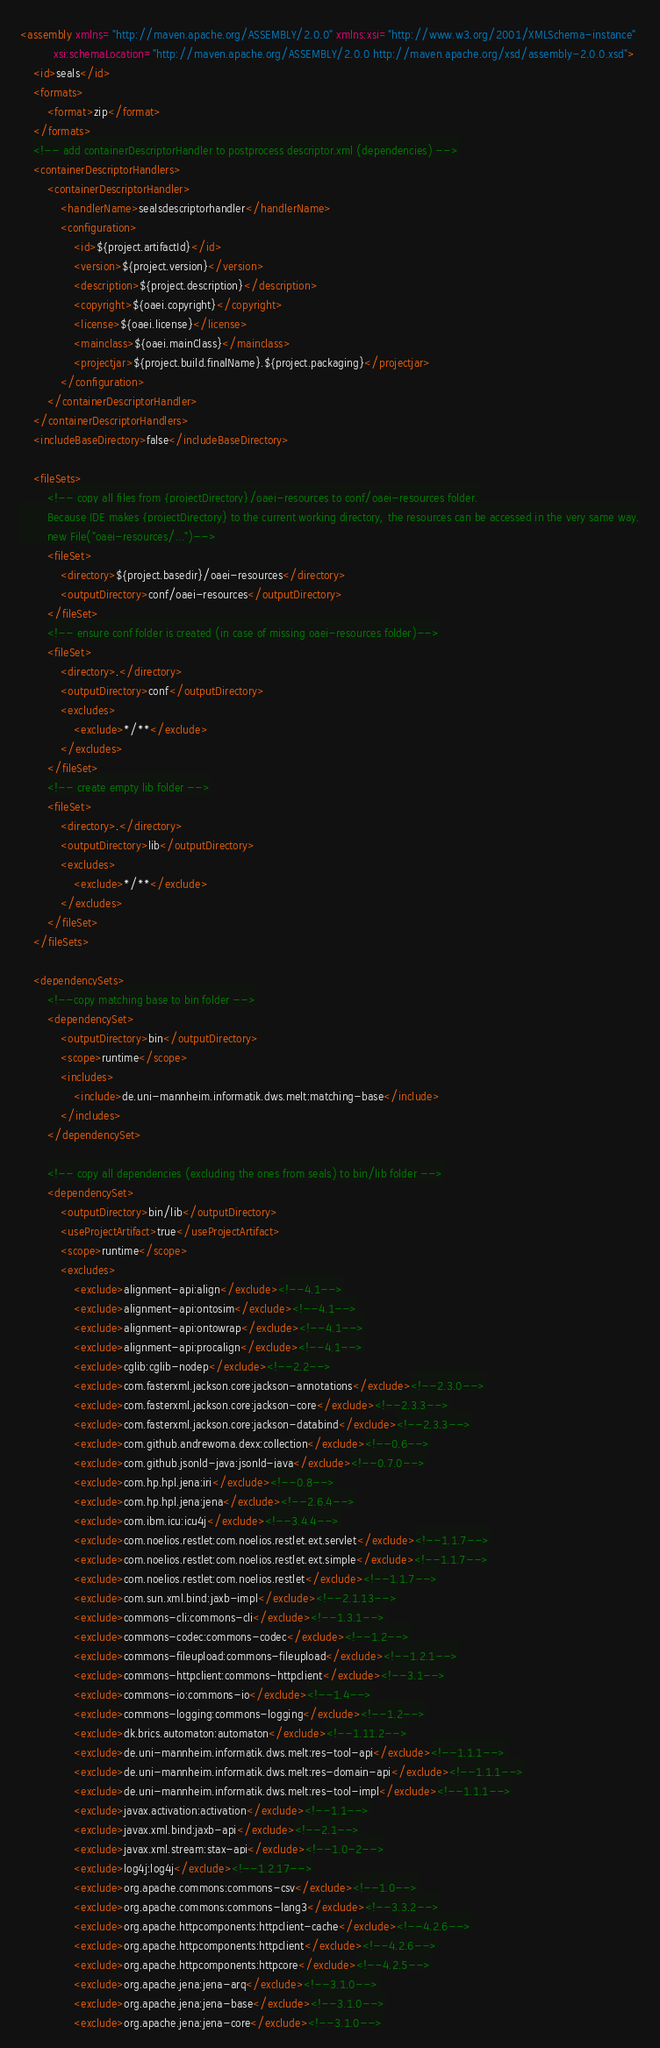<code> <loc_0><loc_0><loc_500><loc_500><_XML_><assembly xmlns="http://maven.apache.org/ASSEMBLY/2.0.0" xmlns:xsi="http://www.w3.org/2001/XMLSchema-instance"
          xsi:schemaLocation="http://maven.apache.org/ASSEMBLY/2.0.0 http://maven.apache.org/xsd/assembly-2.0.0.xsd">
    <id>seals</id>
    <formats>
        <format>zip</format>
    </formats>
    <!-- add containerDescriptorHandler to postprocess descriptor.xml (dependencies) -->
    <containerDescriptorHandlers>
        <containerDescriptorHandler>
            <handlerName>sealsdescriptorhandler</handlerName>
            <configuration>
                <id>${project.artifactId}</id>
                <version>${project.version}</version>
                <description>${project.description}</description>
                <copyright>${oaei.copyright}</copyright>
                <license>${oaei.license}</license>
                <mainclass>${oaei.mainClass}</mainclass>
                <projectjar>${project.build.finalName}.${project.packaging}</projectjar>
            </configuration>
        </containerDescriptorHandler>
    </containerDescriptorHandlers>
    <includeBaseDirectory>false</includeBaseDirectory>
        
    <fileSets>        
        <!-- copy all files from {projectDirectory}/oaei-resources to conf/oaei-resources folder.
        Because IDE makes {projectDirectory} to the current working directory, the resources can be accessed in the very same way.
        new File("oaei-resources/...")-->
        <fileSet>
            <directory>${project.basedir}/oaei-resources</directory>
            <outputDirectory>conf/oaei-resources</outputDirectory>
        </fileSet>
        <!-- ensure conf folder is created (in case of missing oaei-resources folder)-->
        <fileSet>
            <directory>.</directory>
            <outputDirectory>conf</outputDirectory>
            <excludes>
                <exclude>*/**</exclude>
            </excludes>
        </fileSet>
        <!-- create empty lib folder -->
        <fileSet>
            <directory>.</directory>
            <outputDirectory>lib</outputDirectory>
            <excludes>
                <exclude>*/**</exclude>
            </excludes>
        </fileSet>
    </fileSets>
    
    <dependencySets>
        <!--copy matching base to bin folder -->
        <dependencySet>
            <outputDirectory>bin</outputDirectory>
            <scope>runtime</scope>
            <includes>
                <include>de.uni-mannheim.informatik.dws.melt:matching-base</include>
            </includes>
        </dependencySet>
    
        <!-- copy all dependencies (excluding the ones from seals) to bin/lib folder -->
        <dependencySet>
            <outputDirectory>bin/lib</outputDirectory>
            <useProjectArtifact>true</useProjectArtifact>
            <scope>runtime</scope>
            <excludes>
                <exclude>alignment-api:align</exclude><!--4.1-->
                <exclude>alignment-api:ontosim</exclude><!--4.1-->
                <exclude>alignment-api:ontowrap</exclude><!--4.1-->
                <exclude>alignment-api:procalign</exclude><!--4.1-->
                <exclude>cglib:cglib-nodep</exclude><!--2.2-->
                <exclude>com.fasterxml.jackson.core:jackson-annotations</exclude><!--2.3.0-->
                <exclude>com.fasterxml.jackson.core:jackson-core</exclude><!--2.3.3-->
                <exclude>com.fasterxml.jackson.core:jackson-databind</exclude><!--2.3.3-->
                <exclude>com.github.andrewoma.dexx:collection</exclude><!--0.6-->
                <exclude>com.github.jsonld-java:jsonld-java</exclude><!--0.7.0-->
                <exclude>com.hp.hpl.jena:iri</exclude><!--0.8-->
                <exclude>com.hp.hpl.jena:jena</exclude><!--2.6.4-->
                <exclude>com.ibm.icu:icu4j</exclude><!--3.4.4-->
                <exclude>com.noelios.restlet:com.noelios.restlet.ext.servlet</exclude><!--1.1.7-->
                <exclude>com.noelios.restlet:com.noelios.restlet.ext.simple</exclude><!--1.1.7-->
                <exclude>com.noelios.restlet:com.noelios.restlet</exclude><!--1.1.7-->
                <exclude>com.sun.xml.bind:jaxb-impl</exclude><!--2.1.13-->
                <exclude>commons-cli:commons-cli</exclude><!--1.3.1-->
                <exclude>commons-codec:commons-codec</exclude><!--1.2-->
                <exclude>commons-fileupload:commons-fileupload</exclude><!--1.2.1-->
                <exclude>commons-httpclient:commons-httpclient</exclude><!--3.1-->
                <exclude>commons-io:commons-io</exclude><!--1.4-->
                <exclude>commons-logging:commons-logging</exclude><!--1.2-->
                <exclude>dk.brics.automaton:automaton</exclude><!--1.11.2-->
                <exclude>de.uni-mannheim.informatik.dws.melt:res-tool-api</exclude><!--1.1.1-->
                <exclude>de.uni-mannheim.informatik.dws.melt:res-domain-api</exclude><!--1.1.1-->
                <exclude>de.uni-mannheim.informatik.dws.melt:res-tool-impl</exclude><!--1.1.1-->
                <exclude>javax.activation:activation</exclude><!--1.1-->
                <exclude>javax.xml.bind:jaxb-api</exclude><!--2.1-->
                <exclude>javax.xml.stream:stax-api</exclude><!--1.0-2-->
                <exclude>log4j:log4j</exclude><!--1.2.17-->
                <exclude>org.apache.commons:commons-csv</exclude><!--1.0-->
                <exclude>org.apache.commons:commons-lang3</exclude><!--3.3.2-->
                <exclude>org.apache.httpcomponents:httpclient-cache</exclude><!--4.2.6-->
                <exclude>org.apache.httpcomponents:httpclient</exclude><!--4.2.6-->
                <exclude>org.apache.httpcomponents:httpcore</exclude><!--4.2.5-->
                <exclude>org.apache.jena:jena-arq</exclude><!--3.1.0-->
                <exclude>org.apache.jena:jena-base</exclude><!--3.1.0-->
                <exclude>org.apache.jena:jena-core</exclude><!--3.1.0--></code> 